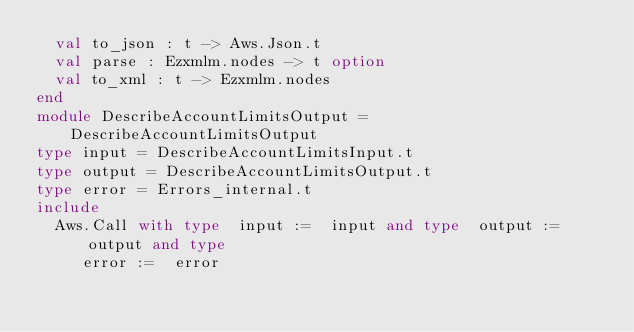<code> <loc_0><loc_0><loc_500><loc_500><_OCaml_>  val to_json : t -> Aws.Json.t
  val parse : Ezxmlm.nodes -> t option
  val to_xml : t -> Ezxmlm.nodes
end
module DescribeAccountLimitsOutput = DescribeAccountLimitsOutput
type input = DescribeAccountLimitsInput.t
type output = DescribeAccountLimitsOutput.t
type error = Errors_internal.t
include
  Aws.Call with type  input :=  input and type  output :=  output and type
     error :=  error</code> 